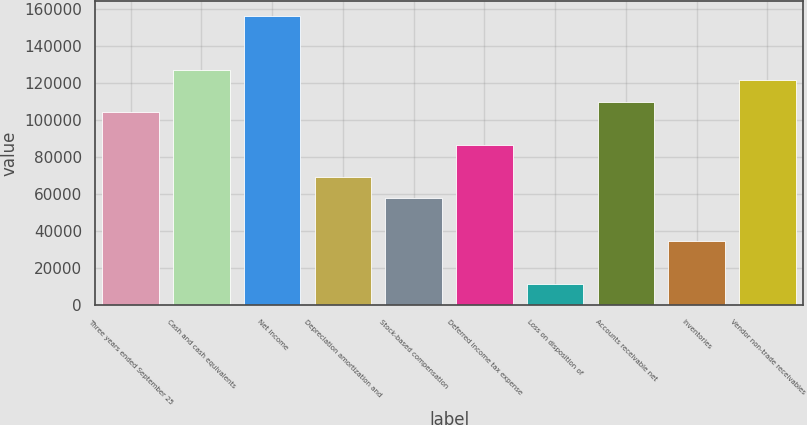<chart> <loc_0><loc_0><loc_500><loc_500><bar_chart><fcel>Three years ended September 25<fcel>Cash and cash equivalents<fcel>Net income<fcel>Depreciation amortization and<fcel>Stock-based compensation<fcel>Deferred income tax expense<fcel>Loss on disposition of<fcel>Accounts receivable net<fcel>Inventories<fcel>Vendor non-trade receivables<nl><fcel>104026<fcel>127142<fcel>156038<fcel>69351.2<fcel>57793<fcel>86688.5<fcel>11560.2<fcel>109805<fcel>34676.6<fcel>121363<nl></chart> 